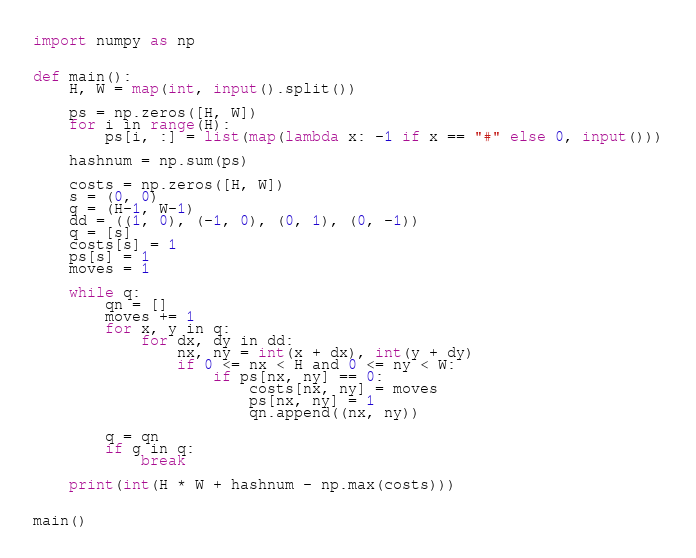<code> <loc_0><loc_0><loc_500><loc_500><_Python_>import numpy as np


def main():
    H, W = map(int, input().split())

    ps = np.zeros([H, W])
    for i in range(H):
        ps[i, :] = list(map(lambda x: -1 if x == "#" else 0, input()))

    hashnum = np.sum(ps)

    costs = np.zeros([H, W])
    s = (0, 0)
    g = (H-1, W-1)
    dd = ((1, 0), (-1, 0), (0, 1), (0, -1))
    q = [s]
    costs[s] = 1
    ps[s] = 1
    moves = 1

    while q:
        qn = []
        moves += 1
        for x, y in q:
            for dx, dy in dd:
                nx, ny = int(x + dx), int(y + dy)
                if 0 <= nx < H and 0 <= ny < W:
                    if ps[nx, ny] == 0:
                        costs[nx, ny] = moves
                        ps[nx, ny] = 1
                        qn.append((nx, ny))

        q = qn
        if g in q:
            break

    print(int(H * W + hashnum - np.max(costs)))


main()
</code> 